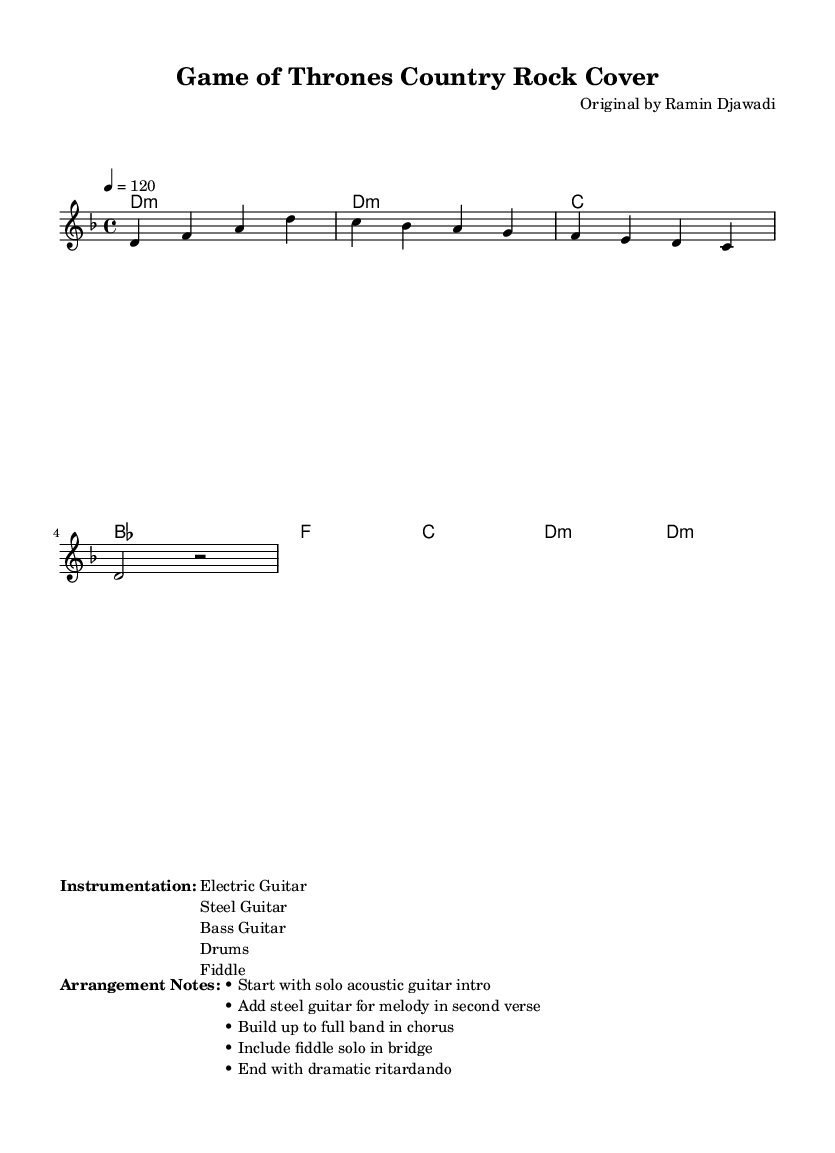What is the title of the piece? The title is prominently displayed at the top of the sheet music, which states "Game of Thrones Country Rock Cover."
Answer: Game of Thrones Country Rock Cover What is the key signature of this music? The key signature is indicated by the key signature marking in the global section labeled as D minor, which corresponds to one flat (B flat).
Answer: D minor What is the time signature of the piece? The time signature appears in the global section as well, displaying a 4/4 notation, meaning there are four beats in each measure.
Answer: 4/4 What is the tempo of the music? The tempo marking in the global section shows "4 = 120," indicating that there are 120 quarter note beats per minute.
Answer: 120 Which instruments are included in the instrumentation? The instrumentation is listed under the markup section highlighting "Electric Guitar," "Steel Guitar," "Bass Guitar," "Drums," and "Fiddle."
Answer: Electric Guitar, Steel Guitar, Bass Guitar, Drums, Fiddle How many measures are in the melody section? The melody section contains a total of four measures, as seen by counting the distinct segments separated by vertical lines.
Answer: 4 What is a notable arrangement element included in the bridge? The arrangement notes mention "Include fiddle solo in bridge," highlighting its significance in the structure of the song.
Answer: Fiddle solo 